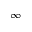Convert formula to latex. <formula><loc_0><loc_0><loc_500><loc_500>\infty</formula> 